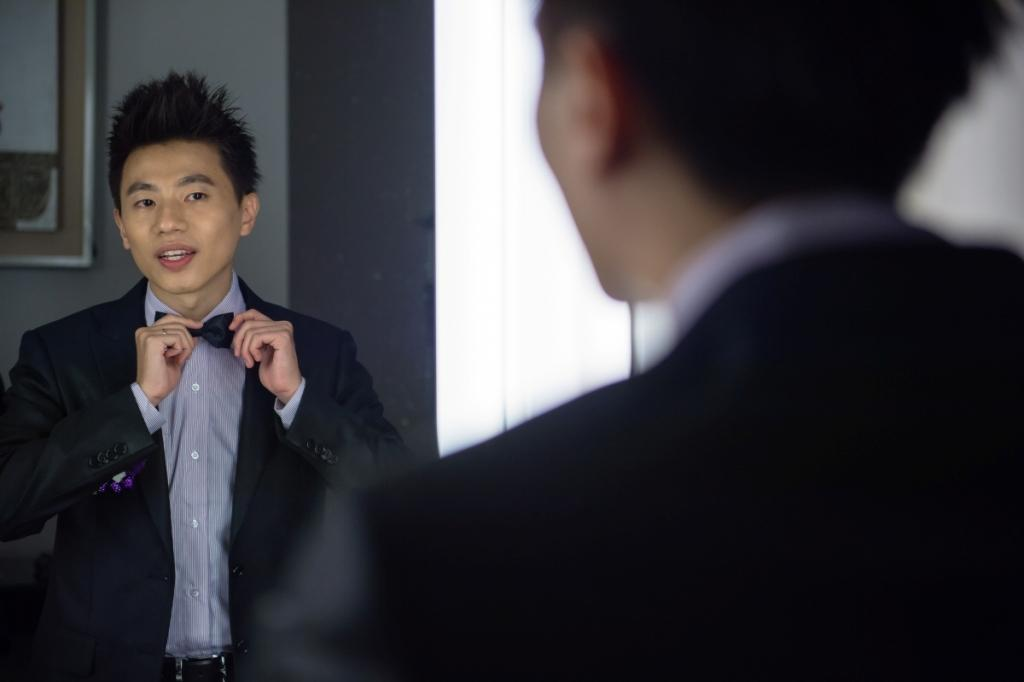What is the main subject of the image? There is a person standing in the image. Can you describe the reflection in the image? There is a reflection of a person standing on the left side of the image, and the person in the reflection is holding a bow tie. What can be seen on the wall in the image? There is a frame on the wall in the image. What type of pail is being used by the person in the image? There is no pail present in the image. Who is the representative of the company in the image? The image does not indicate any specific company or representative. 